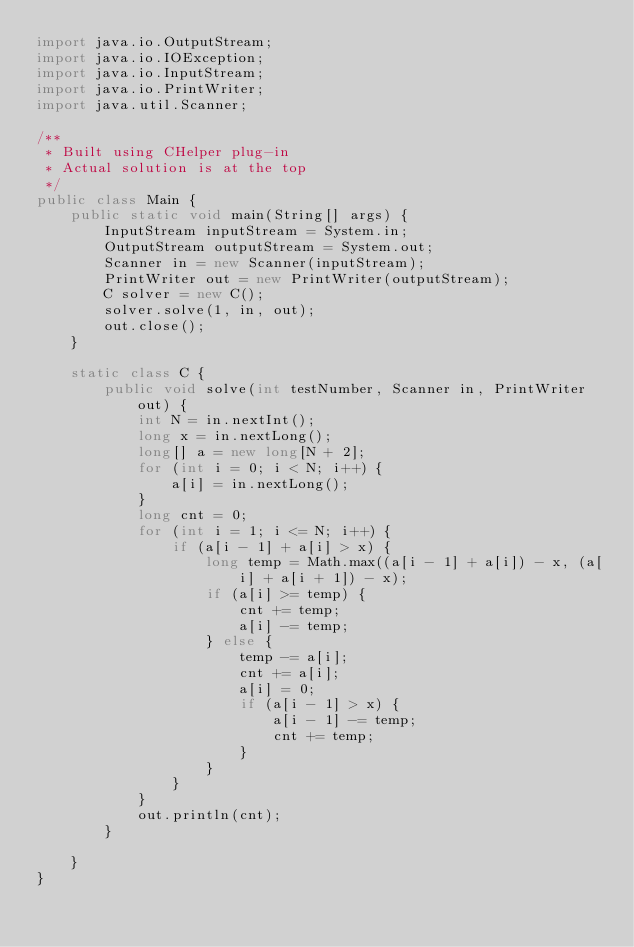<code> <loc_0><loc_0><loc_500><loc_500><_Java_>import java.io.OutputStream;
import java.io.IOException;
import java.io.InputStream;
import java.io.PrintWriter;
import java.util.Scanner;

/**
 * Built using CHelper plug-in
 * Actual solution is at the top
 */
public class Main {
    public static void main(String[] args) {
        InputStream inputStream = System.in;
        OutputStream outputStream = System.out;
        Scanner in = new Scanner(inputStream);
        PrintWriter out = new PrintWriter(outputStream);
        C solver = new C();
        solver.solve(1, in, out);
        out.close();
    }

    static class C {
        public void solve(int testNumber, Scanner in, PrintWriter out) {
            int N = in.nextInt();
            long x = in.nextLong();
            long[] a = new long[N + 2];
            for (int i = 0; i < N; i++) {
                a[i] = in.nextLong();
            }
            long cnt = 0;
            for (int i = 1; i <= N; i++) {
                if (a[i - 1] + a[i] > x) {
                    long temp = Math.max((a[i - 1] + a[i]) - x, (a[i] + a[i + 1]) - x);
                    if (a[i] >= temp) {
                        cnt += temp;
                        a[i] -= temp;
                    } else {
                        temp -= a[i];
                        cnt += a[i];
                        a[i] = 0;
                        if (a[i - 1] > x) {
                            a[i - 1] -= temp;
                            cnt += temp;
                        }
                    }
                }
            }
            out.println(cnt);
        }

    }
}

</code> 